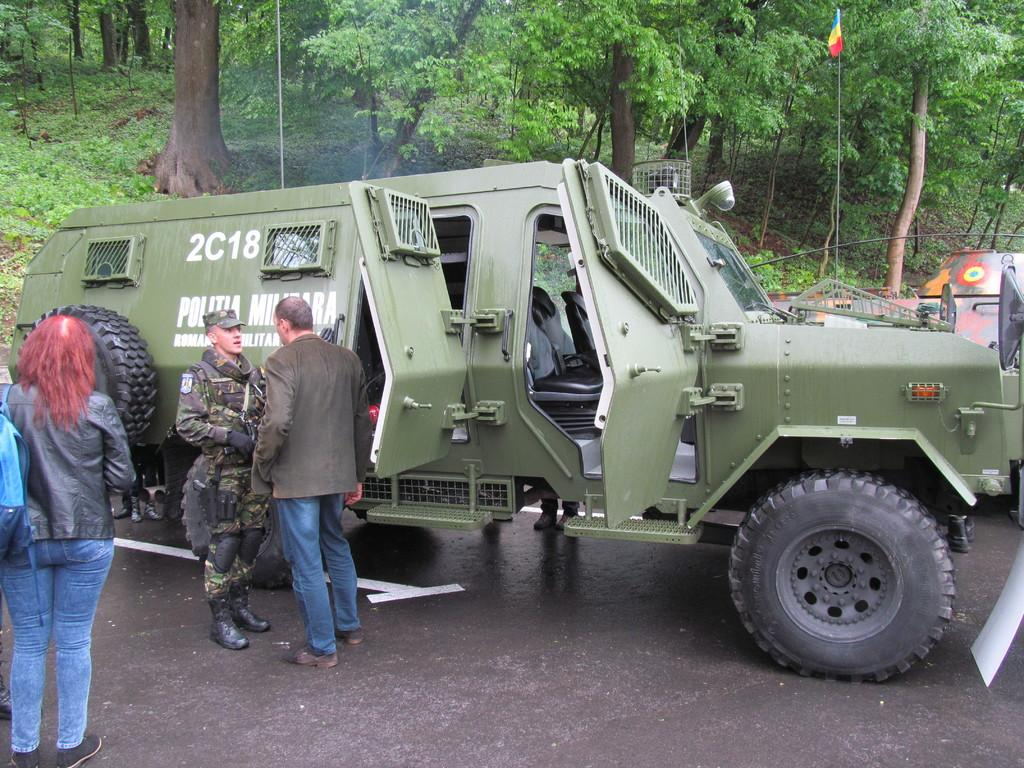What types of objects can be seen in the image? There are vehicles and people standing in the image. Can you describe the environment in the image? There are trees in the background of the image. What type of flowers can be seen growing on the vehicles in the image? There are no flowers growing on the vehicles in the image. 